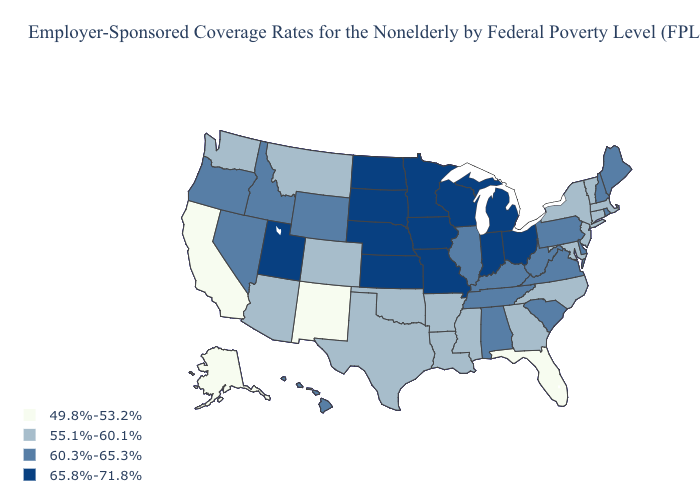Which states have the lowest value in the USA?
Be succinct. Alaska, California, Florida, New Mexico. What is the lowest value in the USA?
Keep it brief. 49.8%-53.2%. Name the states that have a value in the range 49.8%-53.2%?
Write a very short answer. Alaska, California, Florida, New Mexico. Does Maine have a higher value than Wyoming?
Quick response, please. No. What is the value of Louisiana?
Concise answer only. 55.1%-60.1%. Does Kansas have a higher value than North Dakota?
Be succinct. No. What is the lowest value in the USA?
Write a very short answer. 49.8%-53.2%. Name the states that have a value in the range 55.1%-60.1%?
Write a very short answer. Arizona, Arkansas, Colorado, Connecticut, Georgia, Louisiana, Maryland, Massachusetts, Mississippi, Montana, New Jersey, New York, North Carolina, Oklahoma, Texas, Vermont, Washington. What is the value of Texas?
Give a very brief answer. 55.1%-60.1%. Among the states that border Oklahoma , which have the lowest value?
Quick response, please. New Mexico. Does the map have missing data?
Be succinct. No. What is the value of Michigan?
Be succinct. 65.8%-71.8%. Does North Dakota have the highest value in the USA?
Be succinct. Yes. What is the highest value in the USA?
Keep it brief. 65.8%-71.8%. Among the states that border Delaware , does Pennsylvania have the lowest value?
Keep it brief. No. 